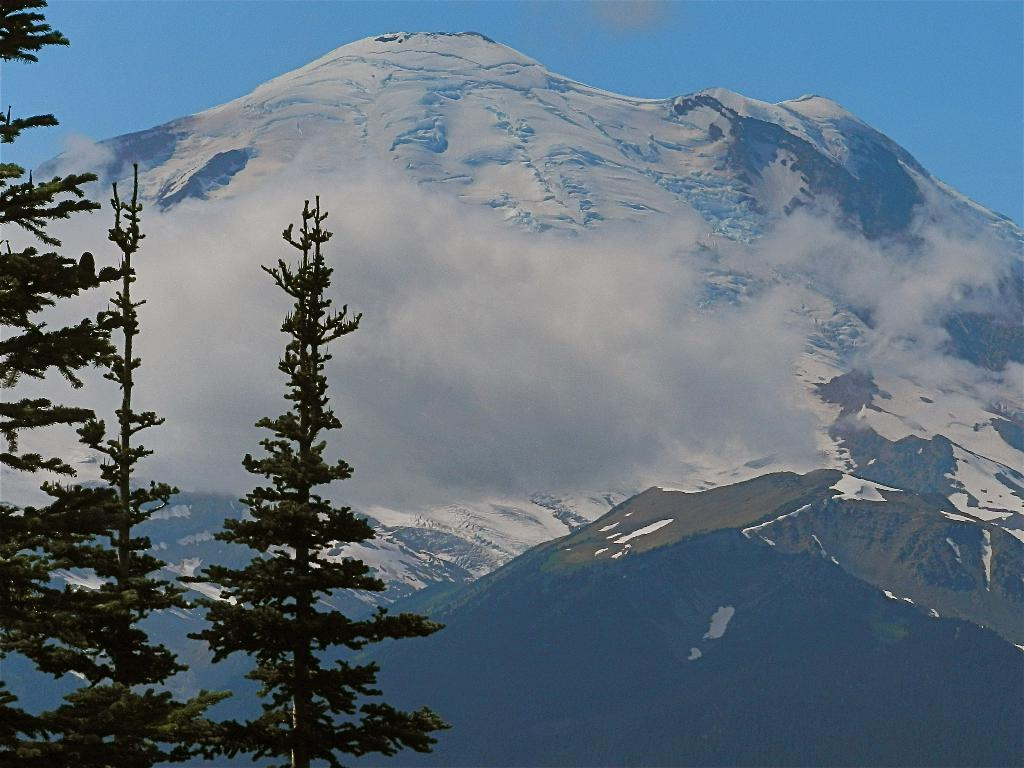What type of vegetation is located in the left corner of the image? There are trees in the left corner of the image. What is behind the trees in the image? There are hills behind the trees. What is the condition of the hills in the image? The hills are covered with ice. What is visible at the top of the image? The sky is visible at the top of the image. What color is the sky in the image? The sky is blue in color. Can you tell me how much money is lying on the ground in the image? There is no mention of money or any currency in the image; it features trees, hills, and a blue sky. What type of wrench is being used to fix the trees in the image? There is no wrench or any tool visible in the image; it only shows trees, hills, and a blue sky. 